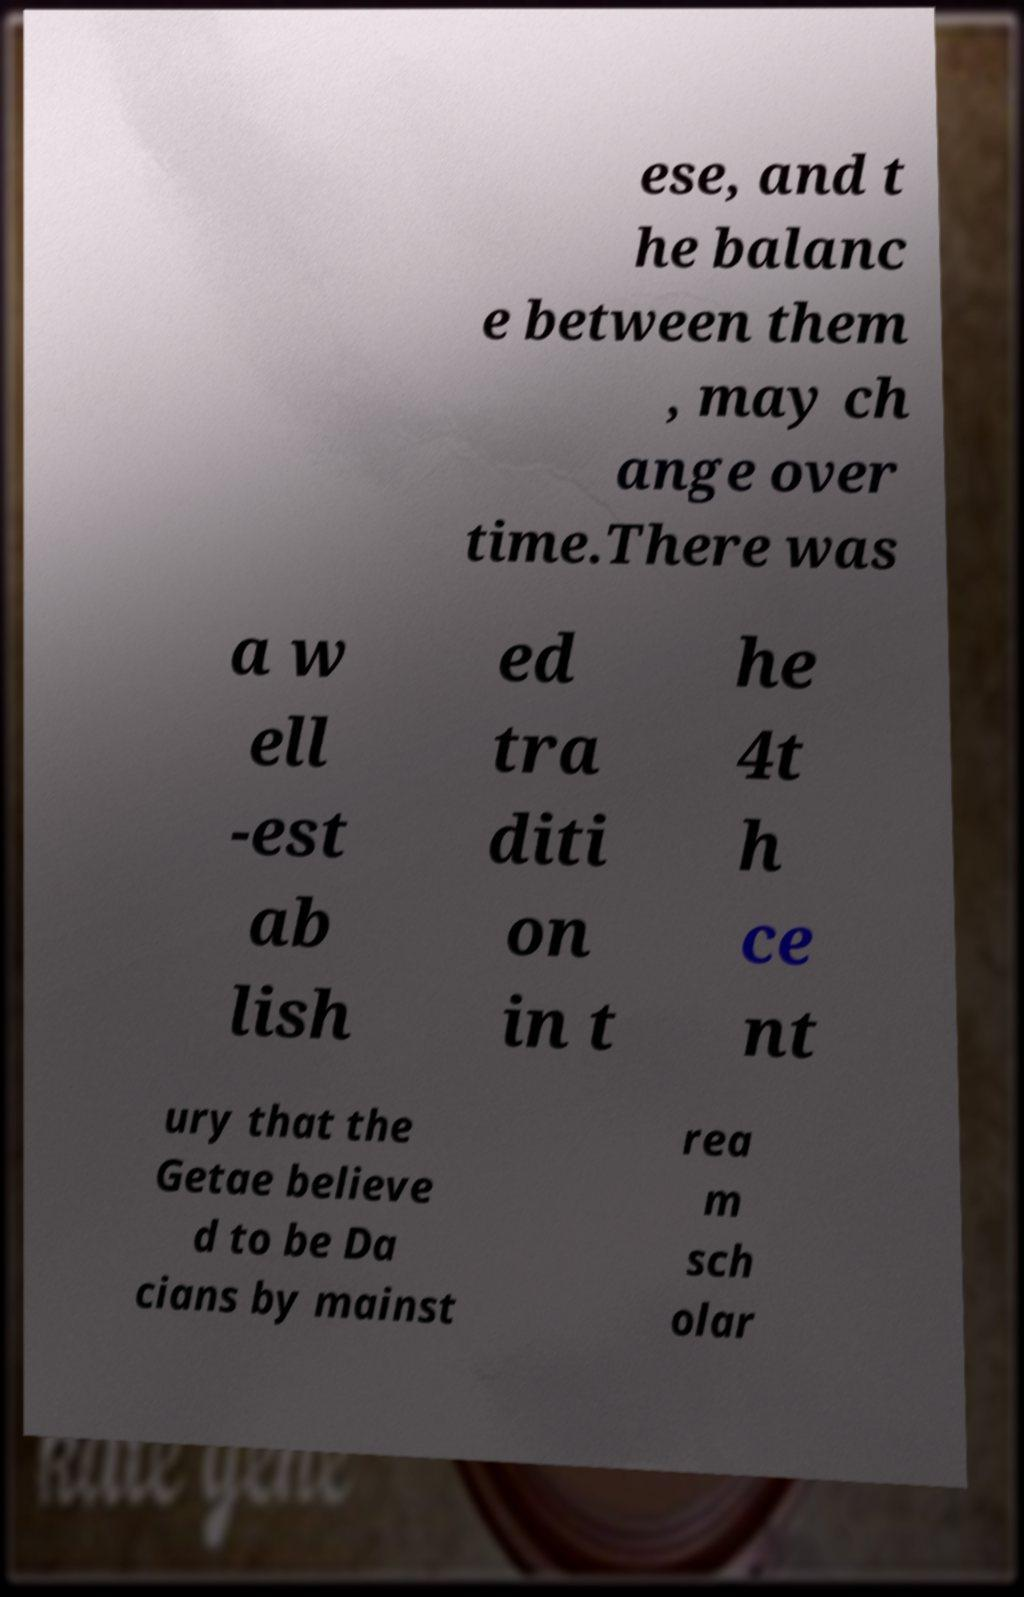Please read and relay the text visible in this image. What does it say? ese, and t he balanc e between them , may ch ange over time.There was a w ell -est ab lish ed tra diti on in t he 4t h ce nt ury that the Getae believe d to be Da cians by mainst rea m sch olar 